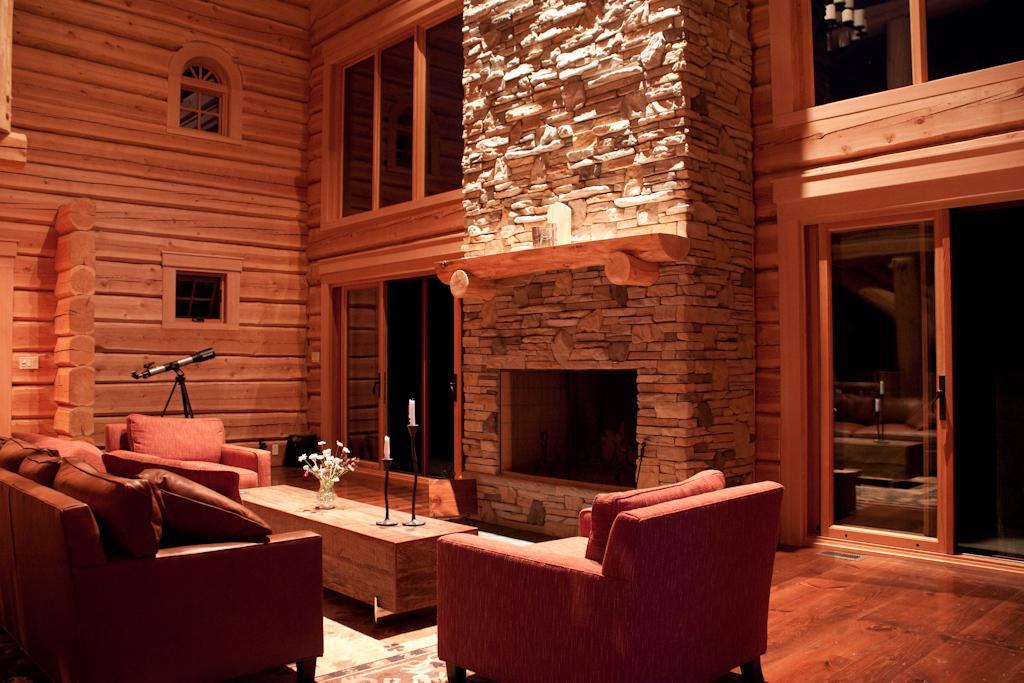In one or two sentences, can you explain what this image depicts? This picture is taken in a room, There are some sofas which are in red color, There is a table which is in brown color, There are some walls of wood in yellow color, In the right side there is a door made up of wood in yellow color. 